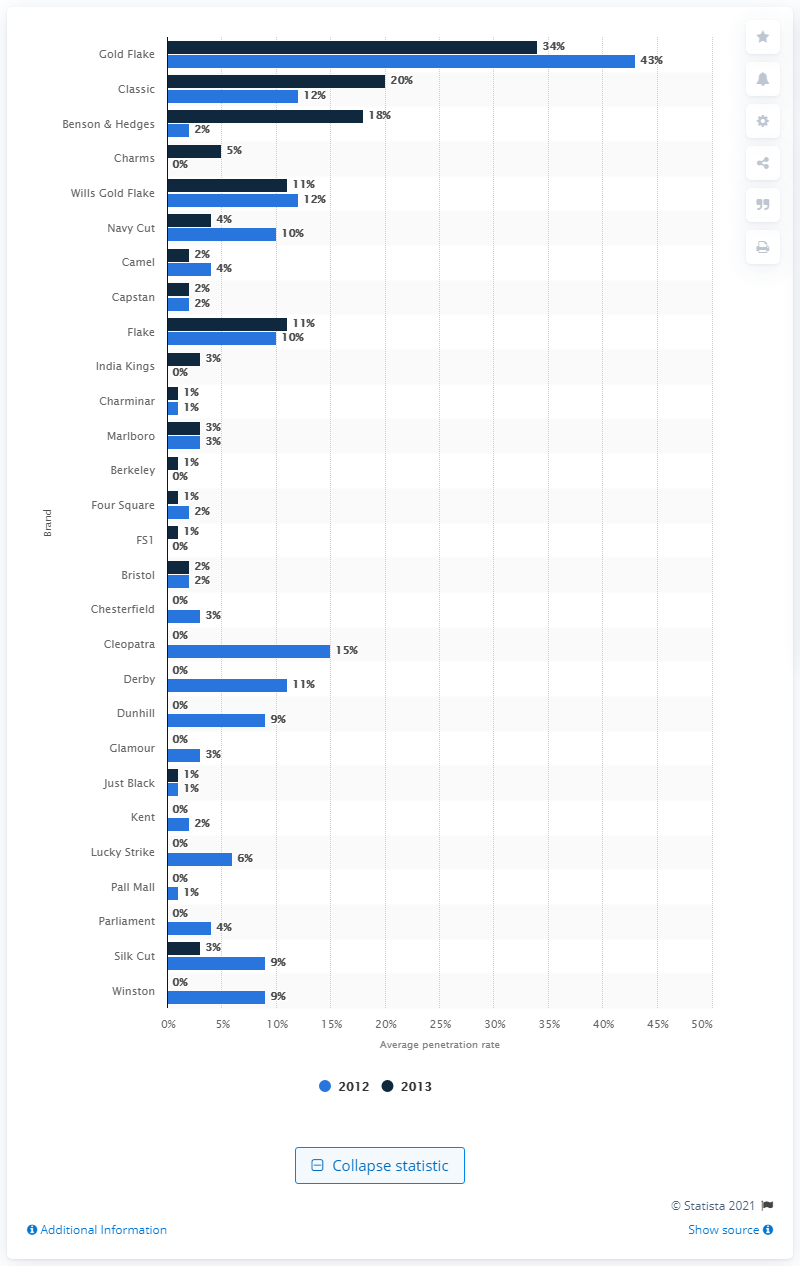Give some essential details in this illustration. In the last three to twelve months of 2013, approximately 5% of Indians purchased Charms cigarettes. 